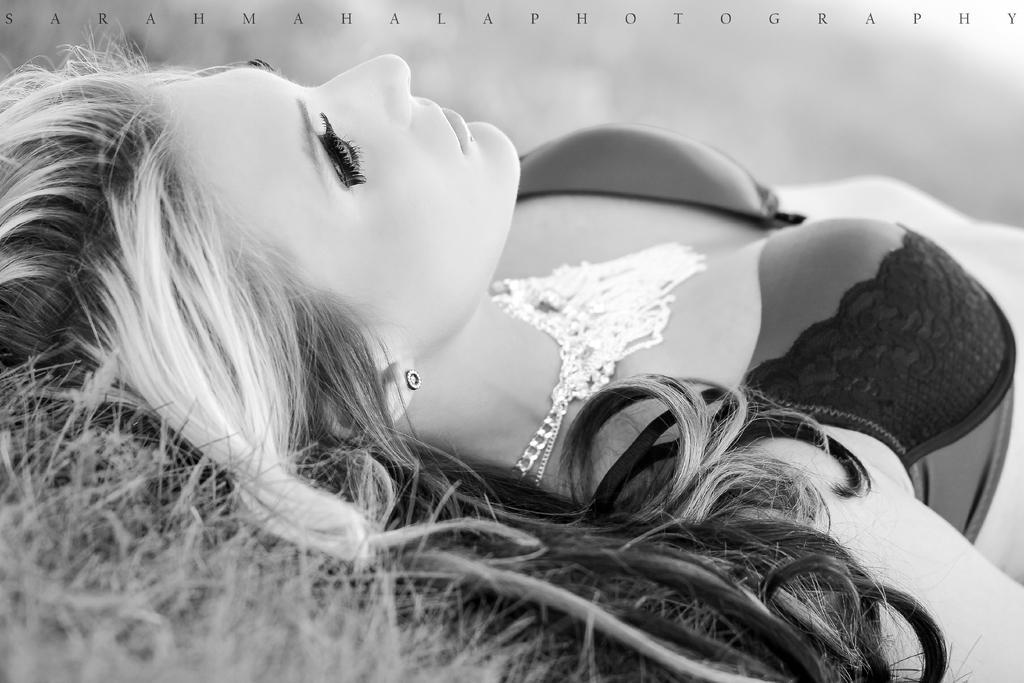In one or two sentences, can you explain what this image depicts? In this image, we can see a woman lying on the grass, she is wearing a jewelry item on her neck. 